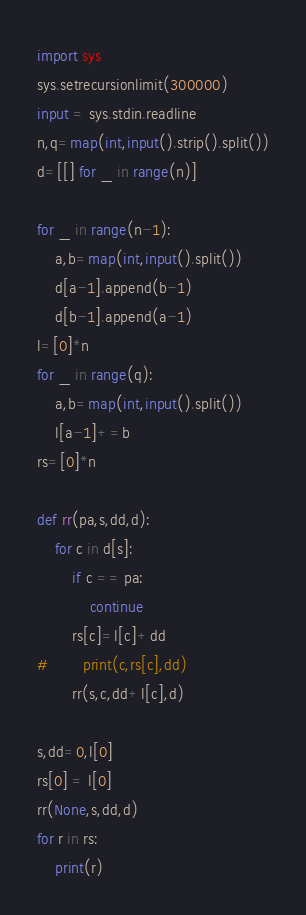<code> <loc_0><loc_0><loc_500><loc_500><_Python_>import sys
sys.setrecursionlimit(300000)
input = sys.stdin.readline
n,q=map(int,input().strip().split())
d=[[] for _ in range(n)]

for _ in range(n-1):
    a,b=map(int,input().split())
    d[a-1].append(b-1)
    d[b-1].append(a-1)
l=[0]*n
for _ in range(q):
    a,b=map(int,input().split())
    l[a-1]+=b
rs=[0]*n

def rr(pa,s,dd,d):
    for c in d[s]:
        if c == pa:
            continue
        rs[c]=l[c]+dd
#        print(c,rs[c],dd)
        rr(s,c,dd+l[c],d)

s,dd=0,l[0]
rs[0] = l[0]
rr(None,s,dd,d)
for r in rs:
    print(r)
</code> 